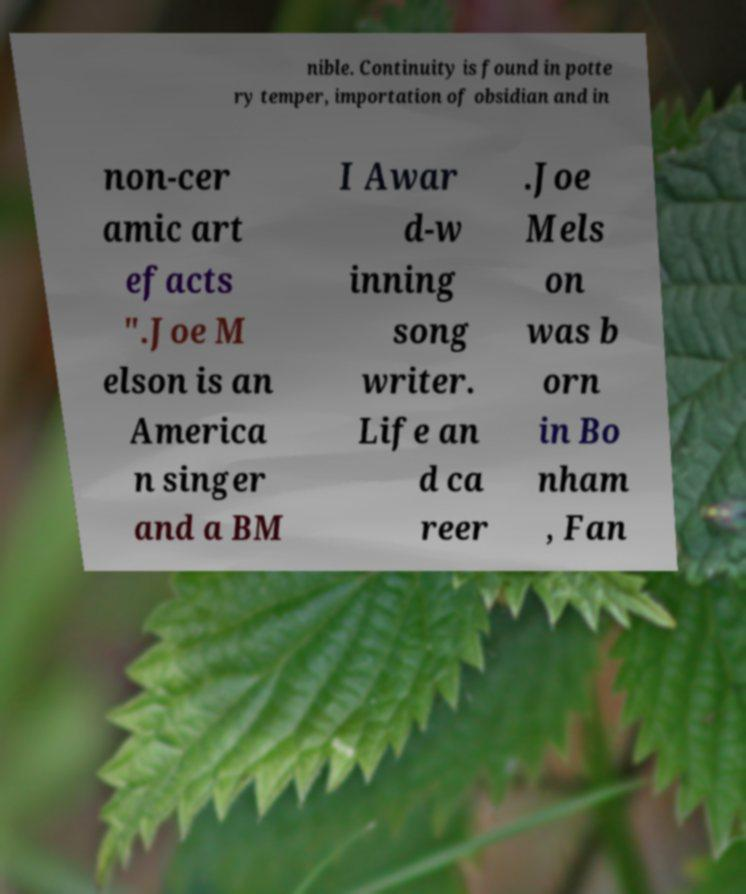Could you assist in decoding the text presented in this image and type it out clearly? nible. Continuity is found in potte ry temper, importation of obsidian and in non-cer amic art efacts ".Joe M elson is an America n singer and a BM I Awar d-w inning song writer. Life an d ca reer .Joe Mels on was b orn in Bo nham , Fan 